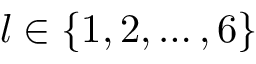Convert formula to latex. <formula><loc_0><loc_0><loc_500><loc_500>l \in \{ 1 , 2 , \dots , 6 \}</formula> 